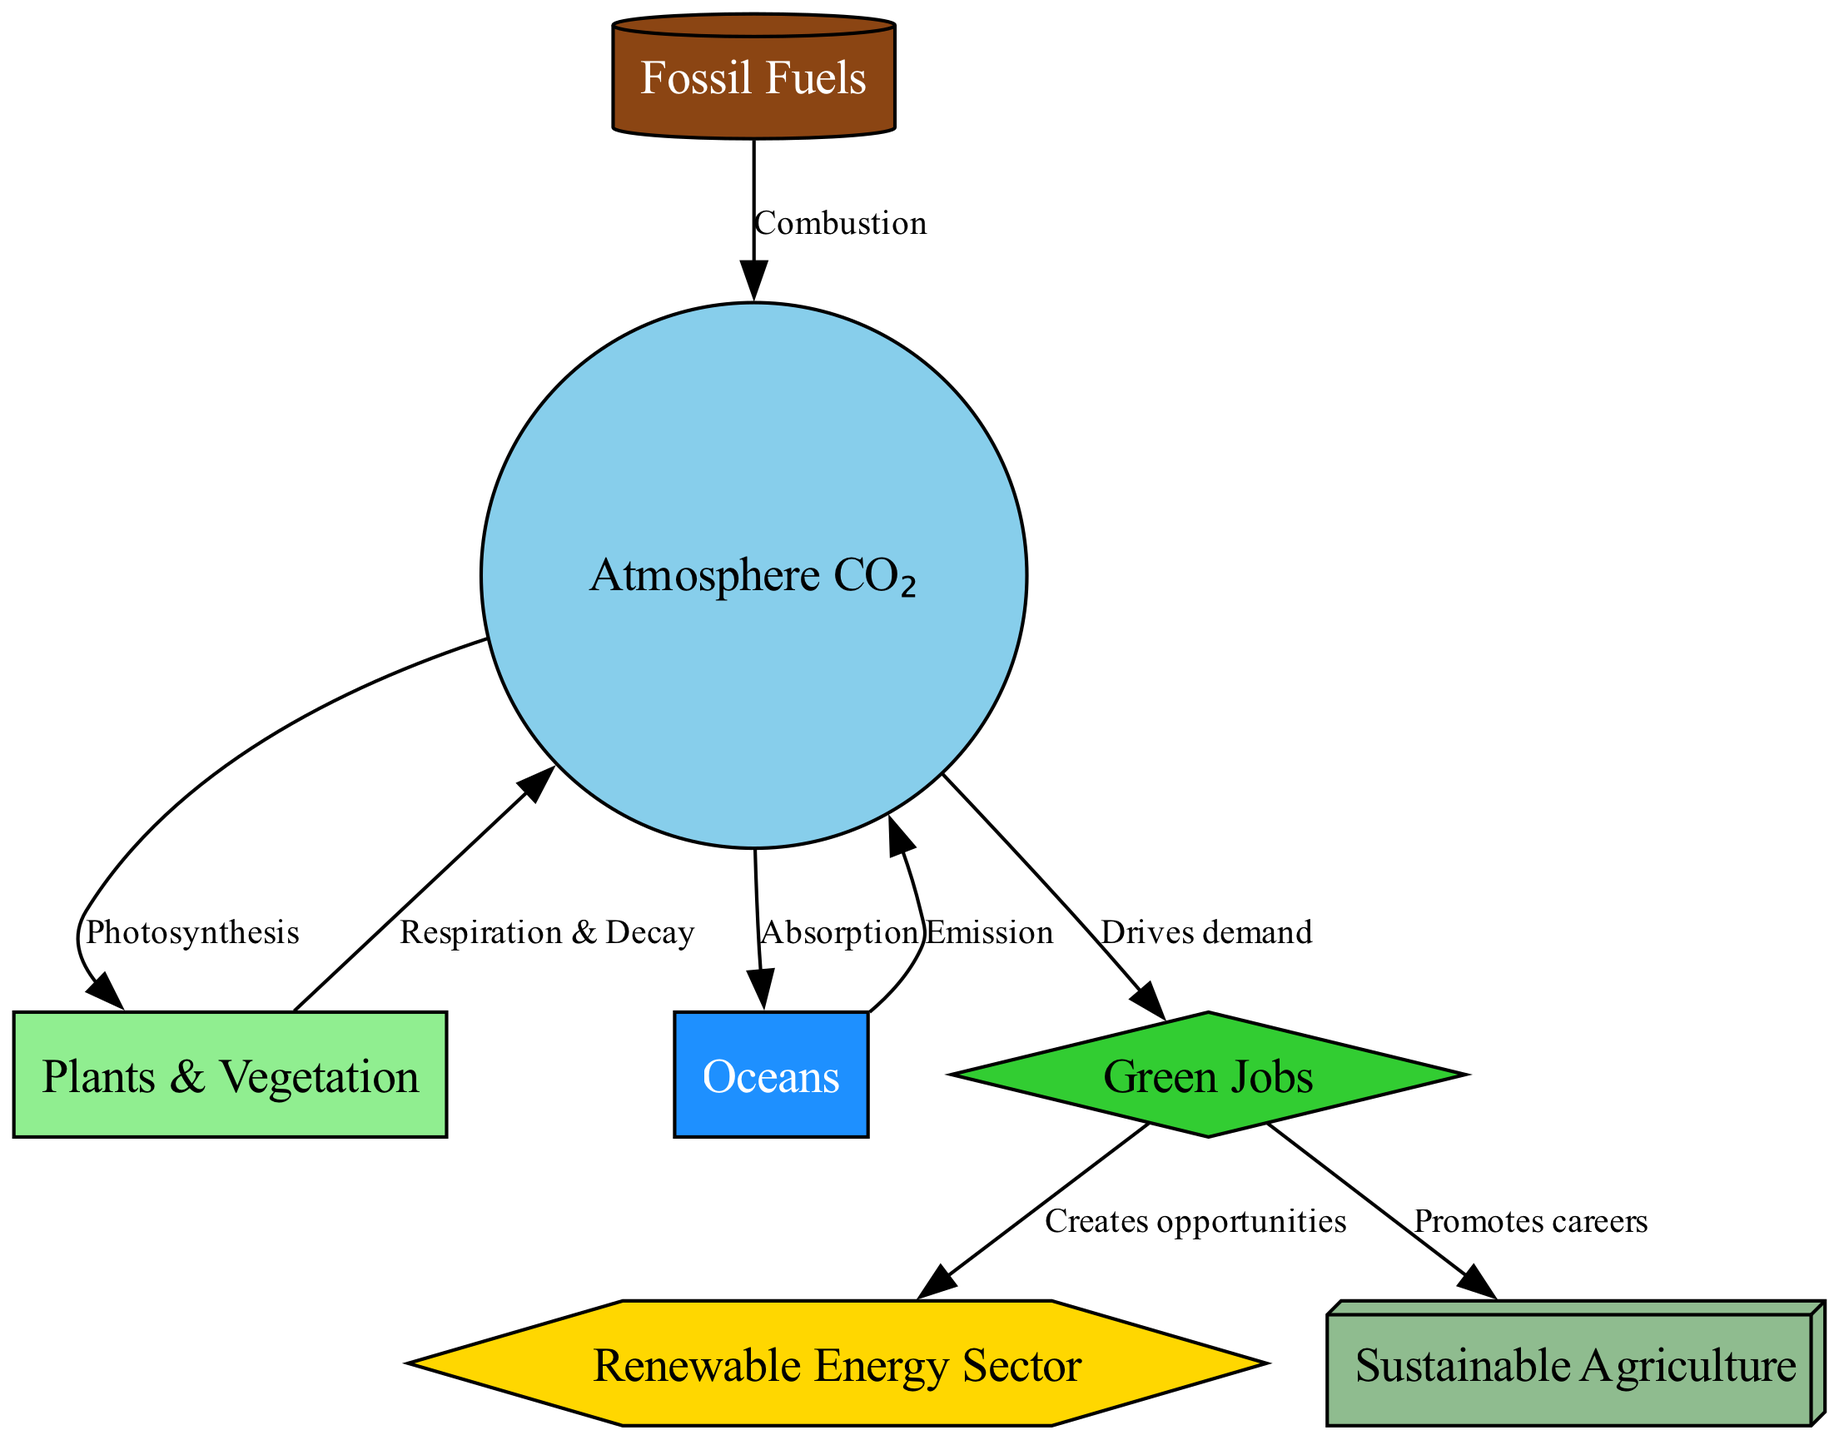What are the main carbon cycle components depicted in the diagram? The components are represented by nodes in the diagram: Atmosphere CO₂, Plants & Vegetation, Oceans, Fossil Fuels, Green Jobs, Renewable Energy Sector, and Sustainable Agriculture.
Answer: Atmosphere CO₂, Plants & Vegetation, Oceans, Fossil Fuels, Green Jobs, Renewable Energy Sector, Sustainable Agriculture How many nodes are in the diagram? The total number of distinct nodes is counted as each unique component: 7 nodes are representing different aspects of the carbon cycle and green jobs.
Answer: 7 What process connects the atmosphere to plants? The relationship between the atmosphere and plants is represented by the directed edge labeled "Photosynthesis," indicating how carbon dioxide is used by plants for growth.
Answer: Photosynthesis Which sector is created as an opportunity from green jobs according to the diagram? The edge leading from green jobs points to the renewable energy sector, indicating that this sector is a key area for job creation stemming from green initiatives.
Answer: Renewable Energy Sector What emission process is represented in this diagram? The diagram includes the "Emission" process, which shows the direction from oceans to the atmosphere, indicating how carbon is released back into the atmosphere from oceanic sources.
Answer: Emission How do green jobs promote careers according to the diagram? The connection from green jobs to sustainable agriculture indicates that these jobs actively support career opportunities in sustainable farming practices, reflecting the demand in environmentally-conscious industries.
Answer: Promotes careers What are the two major flows of carbon from the atmosphere? The diagram illustrates two key processes: Carbon flows from the atmosphere to plants (Photosynthesis) and from the atmosphere to oceans (Absorption), representing critical sinks.
Answer: Plants, Oceans What drives the demand for green jobs based on the diagram? The edge labeled "Drives demand" connects the atmosphere to green jobs, indicating that the level of carbon dioxide in the atmosphere is a significant factor driving the creation and demand for green job roles.
Answer: Drives demand How many edges connect the nodes in this carbon cycle diagram? The diagram shows distinct relationships, particularly edges that represent processes between nodes; there are 8 edges depicting these key flows of carbon and the connections to green jobs.
Answer: 8 